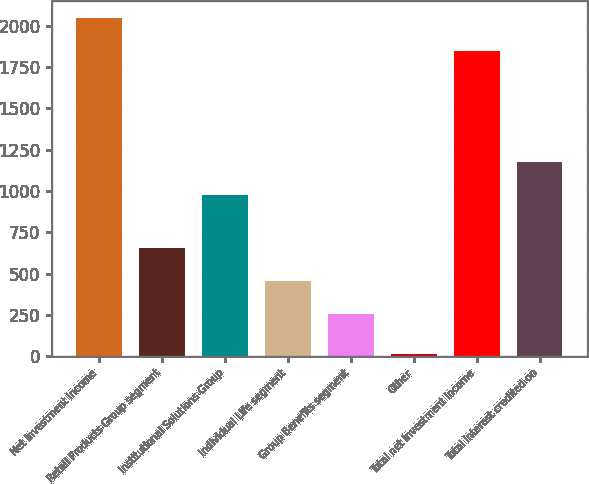<chart> <loc_0><loc_0><loc_500><loc_500><bar_chart><fcel>Net Investment Income<fcel>Retail Products Group segment<fcel>Institutional Solutions Group<fcel>Individual Life segment<fcel>Group Benefits segment<fcel>Other<fcel>Total net investment income<fcel>Total interest credited on<nl><fcel>2047.6<fcel>655.2<fcel>977<fcel>456.6<fcel>258<fcel>16<fcel>1849<fcel>1175.6<nl></chart> 